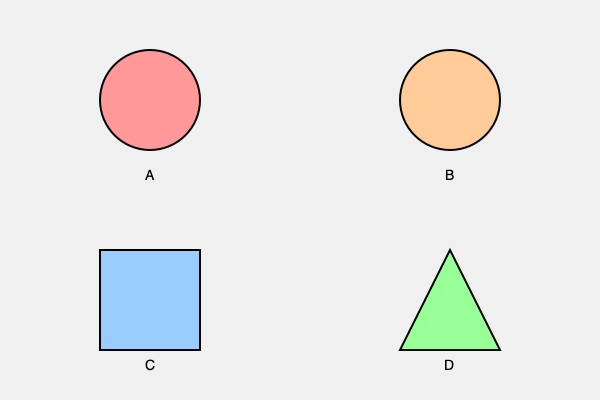Based on the visual characteristics shown in the image, match each skin lesion type (A, B, C, D) with its most likely diagnosis:

1. Erythema migrans
2. Pityriasis rosea
3. Urticaria
4. Tinea corporis To correctly identify these skin lesions, we need to analyze their visual characteristics:

A. Circular, red lesion with a clear border: This is typical of erythema migrans, the characteristic rash of Lyme disease. It often appears as a "bull's-eye" pattern with central clearing.

B. Circular, slightly raised lesion with a scaly border: This pattern is consistent with tinea corporis, also known as ringworm. It typically presents as a circular, red, scaly patch that expands outward.

C. Rectangular, blue-tinted patch: While not a common presentation, this could represent a patch of pityriasis rosea. Pityriasis rosea often begins with a "herald patch" followed by smaller, oval-shaped lesions, but can sometimes present in various shapes and colors.

D. Triangular, raised, green-tinted lesion: This shape and color are most consistent with urticaria, also known as hives. Urticaria can present in various shapes and sizes, often as raised, itchy welts that can be pale or red.

By matching the visual characteristics with the typical presentations of these skin conditions, we can deduce the most likely diagnoses for each lesion.
Answer: A: 1 (Erythema migrans), B: 4 (Tinea corporis), C: 2 (Pityriasis rosea), D: 3 (Urticaria) 